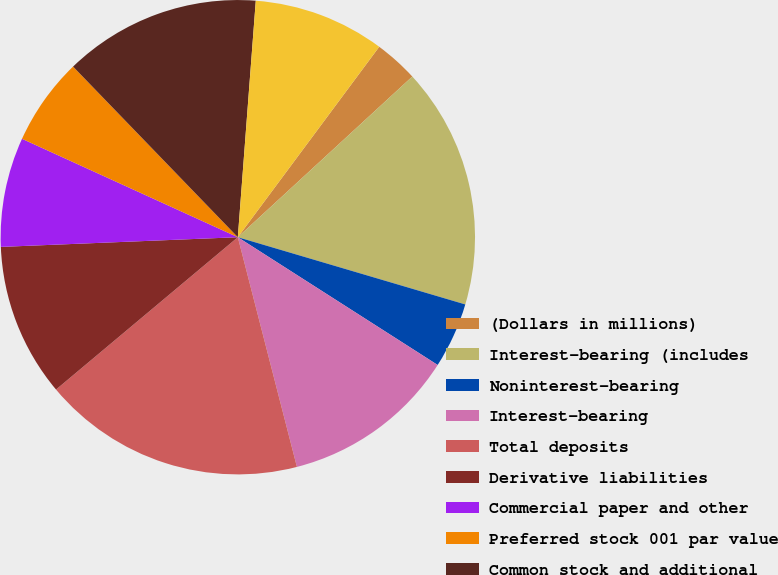Convert chart. <chart><loc_0><loc_0><loc_500><loc_500><pie_chart><fcel>(Dollars in millions)<fcel>Interest-bearing (includes<fcel>Noninterest-bearing<fcel>Interest-bearing<fcel>Total deposits<fcel>Derivative liabilities<fcel>Commercial paper and other<fcel>Preferred stock 001 par value<fcel>Common stock and additional<fcel>Retained earnings<nl><fcel>2.99%<fcel>16.42%<fcel>4.48%<fcel>11.94%<fcel>17.91%<fcel>10.45%<fcel>7.46%<fcel>5.97%<fcel>13.43%<fcel>8.96%<nl></chart> 